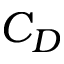Convert formula to latex. <formula><loc_0><loc_0><loc_500><loc_500>C _ { D }</formula> 